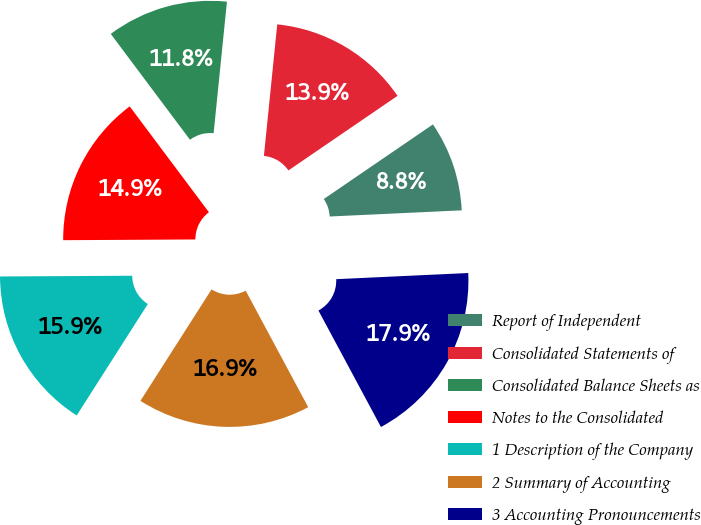Convert chart. <chart><loc_0><loc_0><loc_500><loc_500><pie_chart><fcel>Report of Independent<fcel>Consolidated Statements of<fcel>Consolidated Balance Sheets as<fcel>Notes to the Consolidated<fcel>1 Description of the Company<fcel>2 Summary of Accounting<fcel>3 Accounting Pronouncements<nl><fcel>8.8%<fcel>13.85%<fcel>11.83%<fcel>14.86%<fcel>15.87%<fcel>16.88%<fcel>17.9%<nl></chart> 